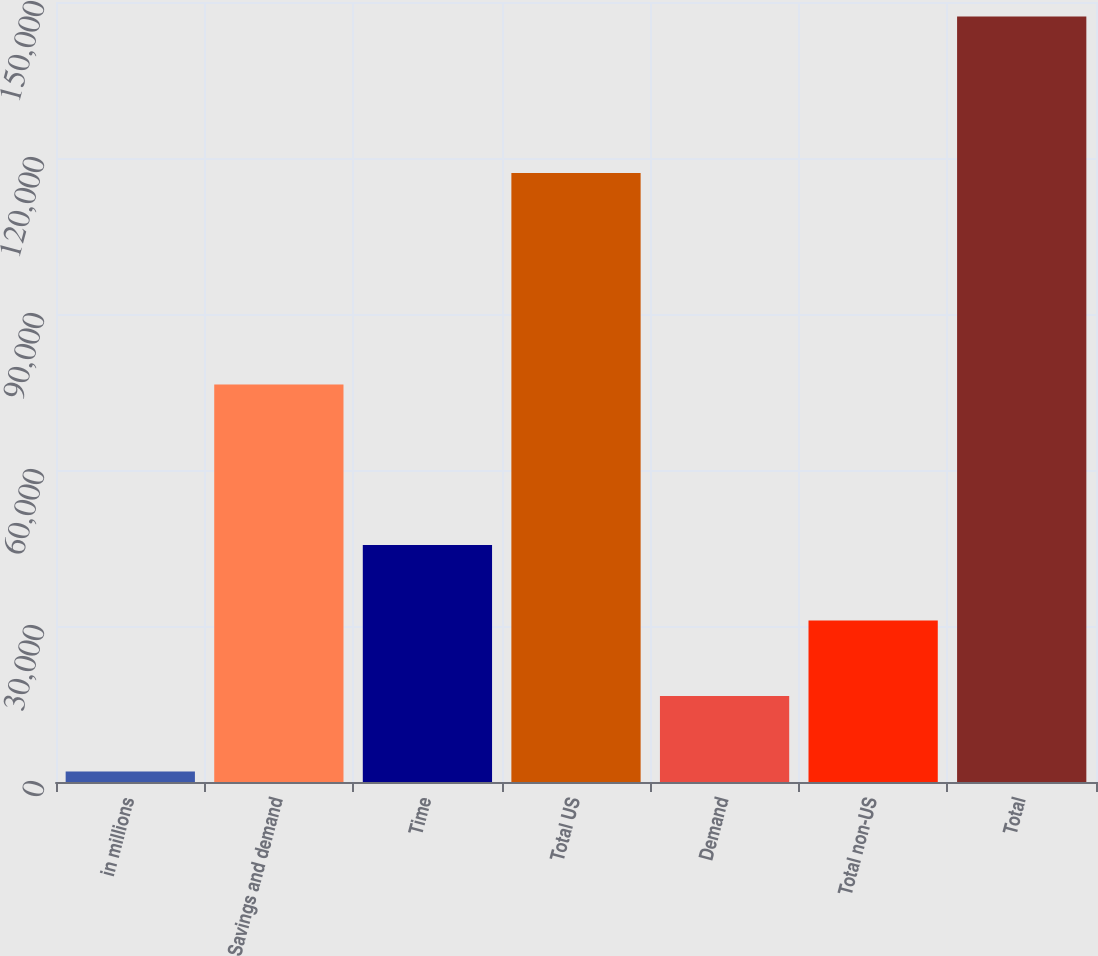<chart> <loc_0><loc_0><loc_500><loc_500><bar_chart><fcel>in millions<fcel>Savings and demand<fcel>Time<fcel>Total US<fcel>Demand<fcel>Total non-US<fcel>Total<nl><fcel>2018<fcel>76428<fcel>45570.2<fcel>117121<fcel>16535.4<fcel>31052.8<fcel>147192<nl></chart> 